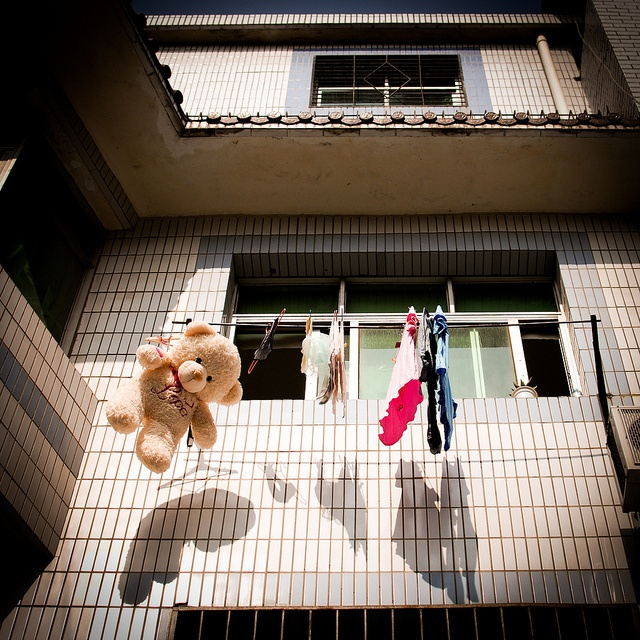Describe the objects in this image and their specific colors. I can see a teddy bear in black, tan, brown, and ivory tones in this image. 